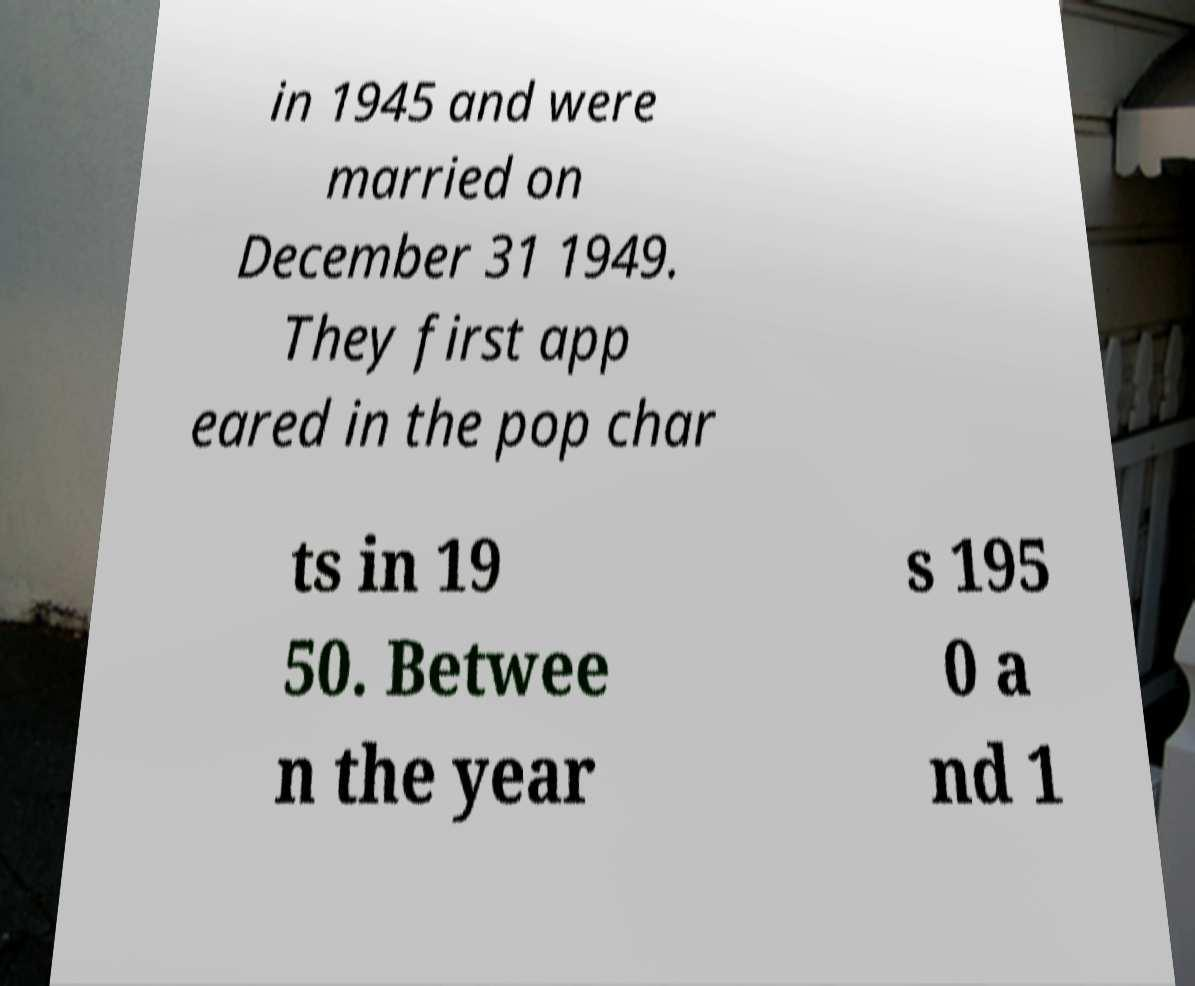Please read and relay the text visible in this image. What does it say? in 1945 and were married on December 31 1949. They first app eared in the pop char ts in 19 50. Betwee n the year s 195 0 a nd 1 